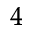<formula> <loc_0><loc_0><loc_500><loc_500>^ { 4 }</formula> 